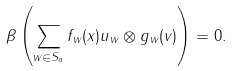Convert formula to latex. <formula><loc_0><loc_0><loc_500><loc_500>\beta \left ( \sum _ { w \in S _ { a } } f _ { w } ( x ) u _ { w } \otimes g _ { w } ( v ) \right ) = 0 .</formula> 